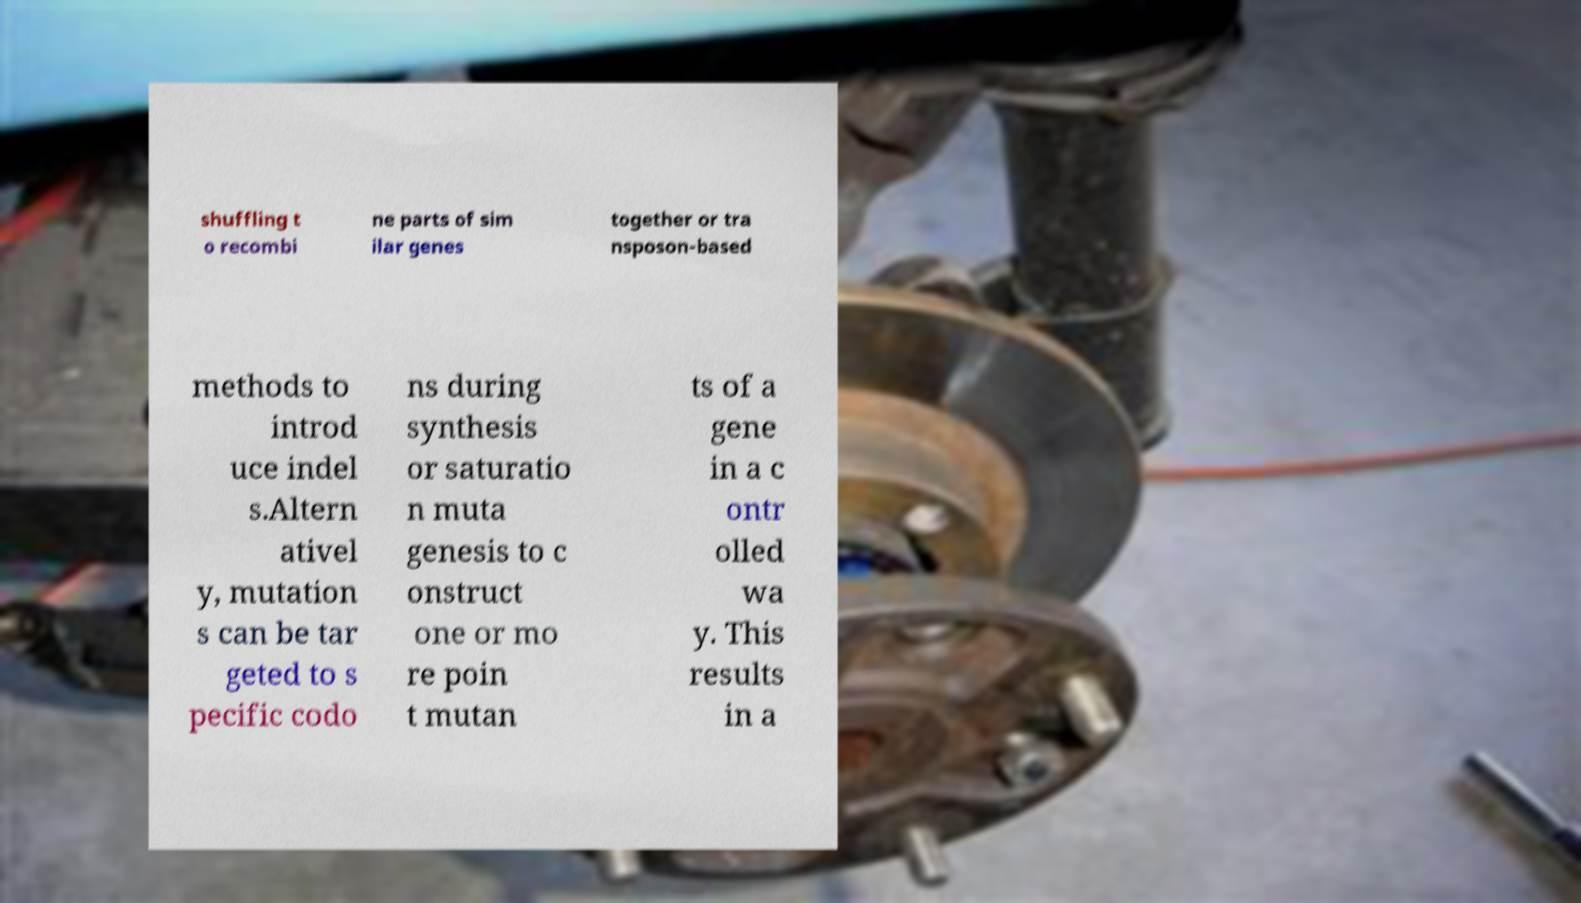Could you assist in decoding the text presented in this image and type it out clearly? shuffling t o recombi ne parts of sim ilar genes together or tra nsposon-based methods to introd uce indel s.Altern ativel y, mutation s can be tar geted to s pecific codo ns during synthesis or saturatio n muta genesis to c onstruct one or mo re poin t mutan ts of a gene in a c ontr olled wa y. This results in a 